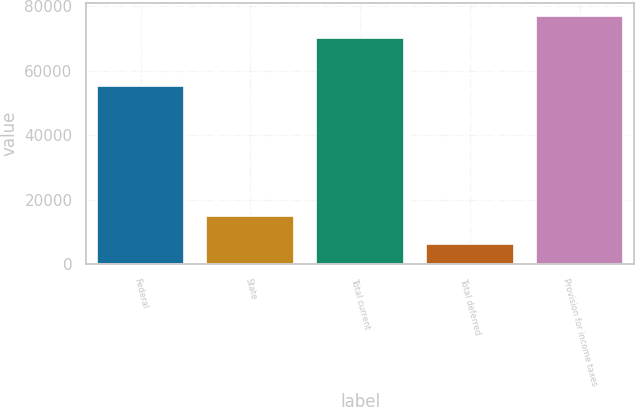Convert chart. <chart><loc_0><loc_0><loc_500><loc_500><bar_chart><fcel>Federal<fcel>State<fcel>Total current<fcel>Total deferred<fcel>Provision for income taxes<nl><fcel>55104<fcel>14900<fcel>70004<fcel>6328<fcel>77004.4<nl></chart> 